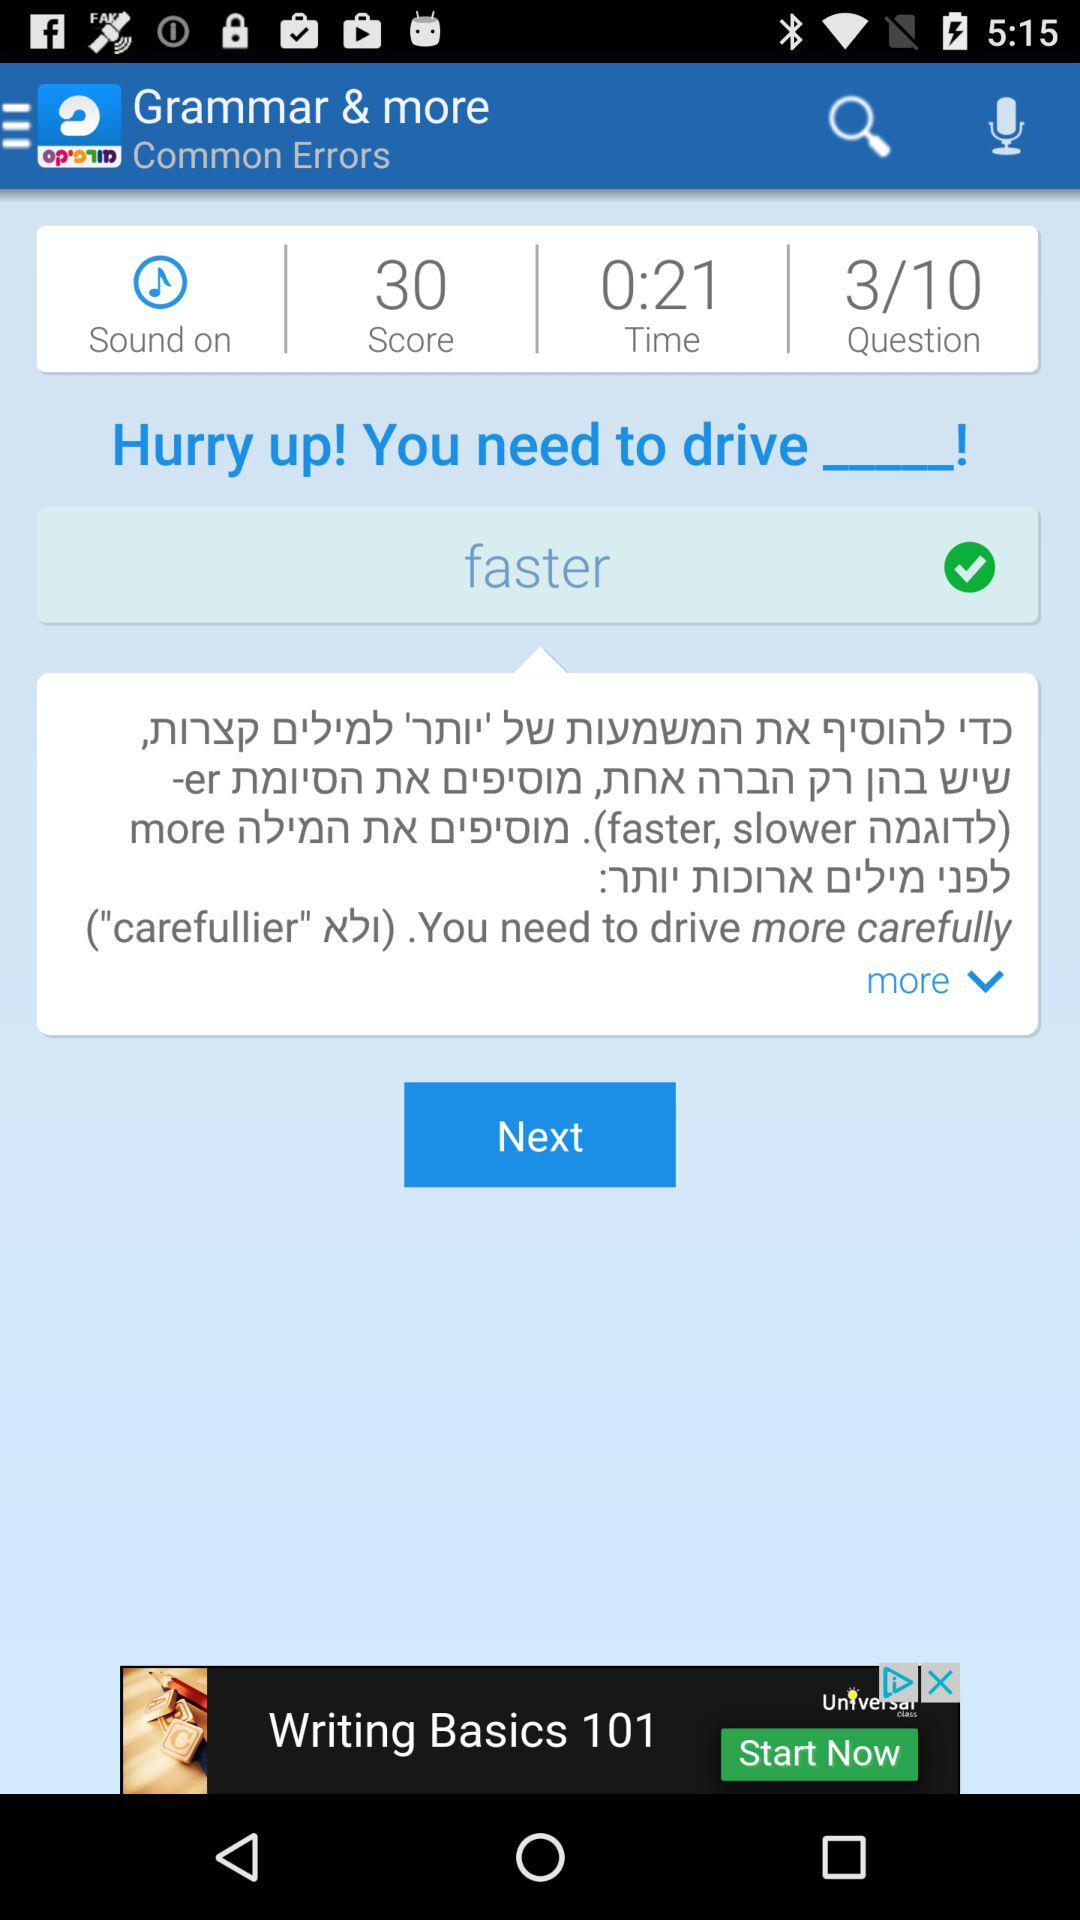How much time did the questions take? The question took 21 seconds. 